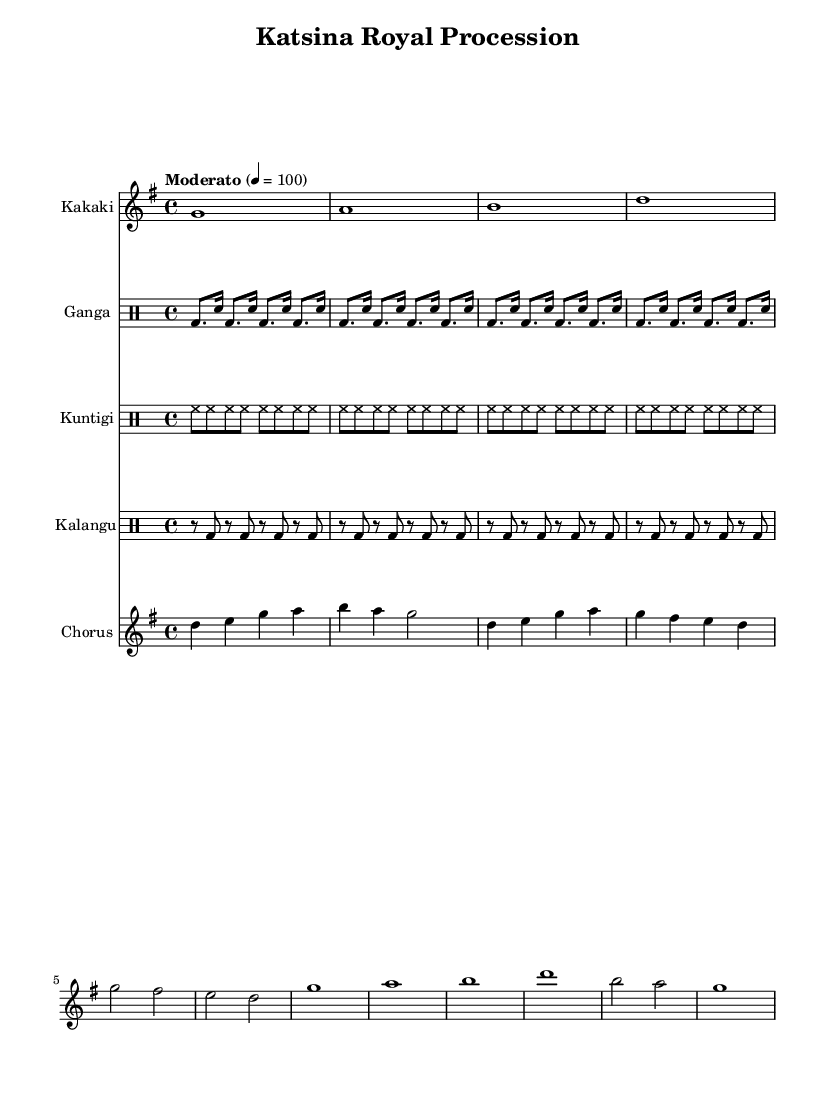What is the key signature of this music? The key signature is G major, which has one sharp (F sharps). This can be identified by looking at the key signature section at the beginning of the staff.
Answer: G major What is the time signature of the piece? The time signature indicated on the score is 4/4, which means there are four beats per measure. This is found just after the key signature at the beginning of the score.
Answer: 4/4 What is the tempo marking for this piece? The tempo marking is "Moderato", which suggests a moderate pace of 100 beats per minute. It is typically notated above the first measure of the score.
Answer: Moderato How many measures does the kakaki part have? The kakaki part appears to have 8 measures in total based on the notation provided for this instrument. Each measure is separated by a vertical line, which can be counted directly on the staff.
Answer: 8 What instruments are featured in this piece? The instruments present in the score include Kakaki, Ganga, Kuntigi, Kalangu, and Chorus. They are labeled at the beginning of each staff, showing the instrumentation used in the performance.
Answer: Kakaki, Ganga, Kuntigi, Kalangu, Chorus What is the primary lyrical theme expressed in the chorus? The primary lyrical theme expressed in the chorus revolves around praising the traditions of Katsina and its pride. This is summarized in the lyrics themselves, which highlight loyalty to traditional values.
Answer: Praise to our Emir 